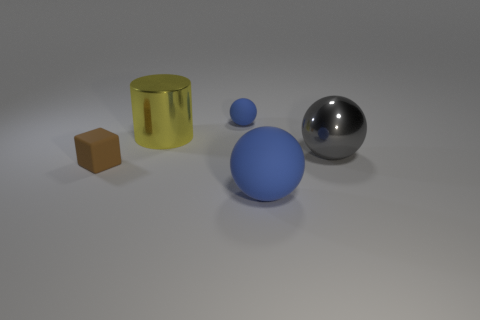What can you tell me about the differences in textures of the objects in this image? The objects exhibit a variety of textures. The large blue sphere has a smooth and uniform surface, implying a solid, possibly plastic material. In contrast, the yellow cylindrical object displays a slightly translucent appearance with visible flexure lines, suggesting a rubber-like material. The small brown cube appears rough, indicative of a matte, possibly wooden material. Lastly, the reflective sphere has a high-gloss finish, consistent with polished metal. 